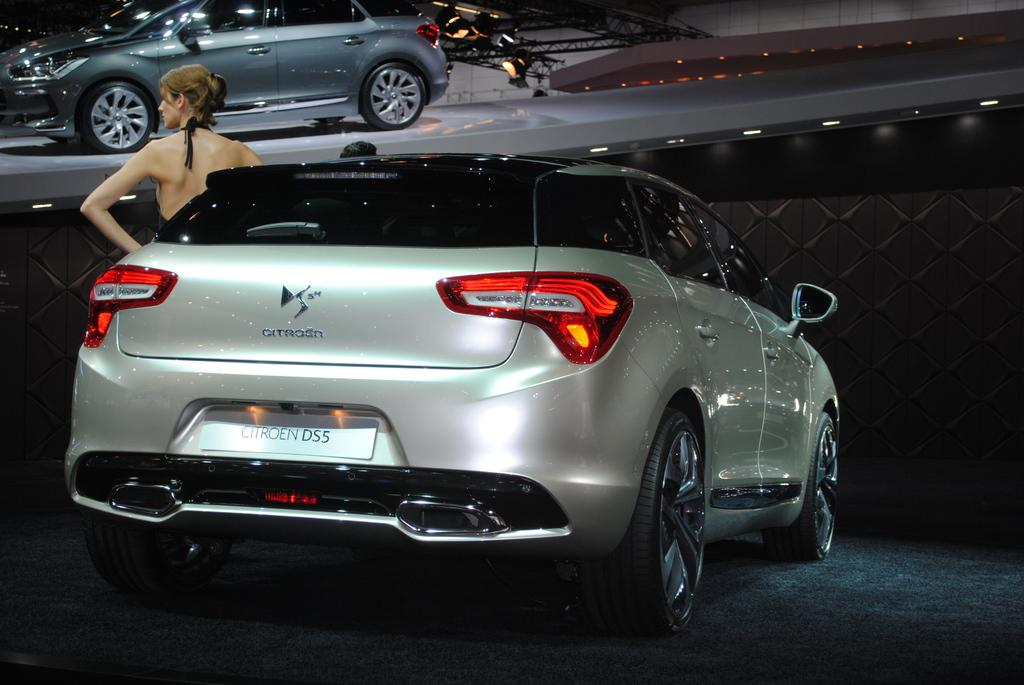What is the main subject of the image? There is a woman standing in the center of the image. What else can be seen in the image besides the woman? There is a car, a wall, lights, ropes, and another car visible in the background of the image. Can you describe the background of the image? The background of the image includes a wall, lights, ropes, and another car. Are there any other objects visible in the background of the image? Yes, there are other objects visible in the background of the image. What type of creature is responsible for the expansion of the wall in the image? There is no creature present in the image, and the wall does not appear to be expanding. 